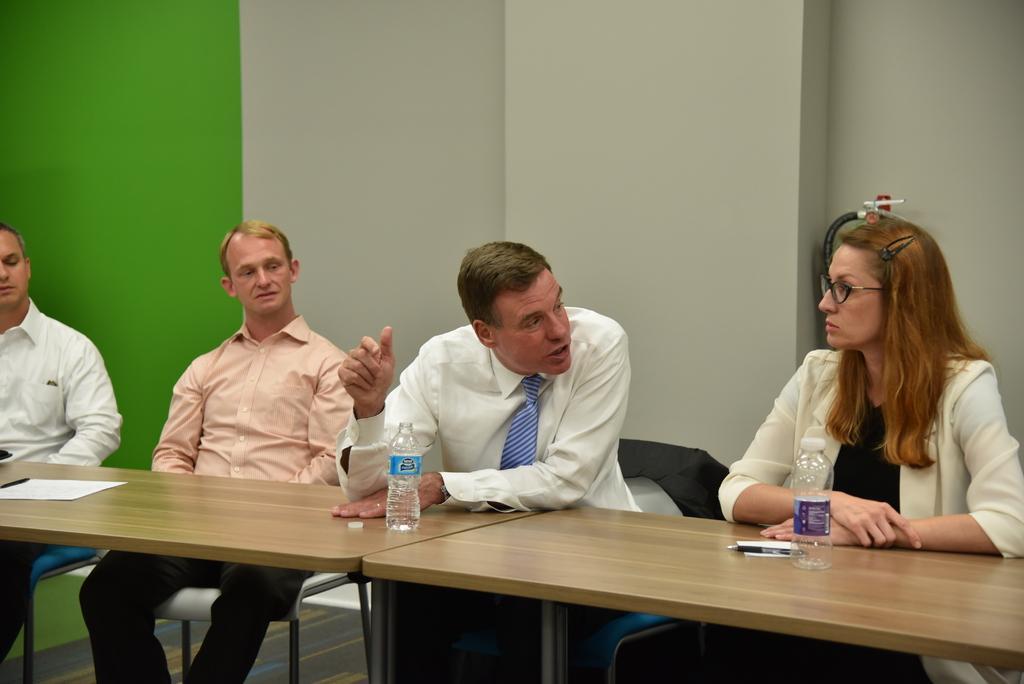Describe this image in one or two sentences. In this image we can see people sitting on the chairs and tables placed in front of them. In the background we can see walls, disposal bottles, paper and pens. 